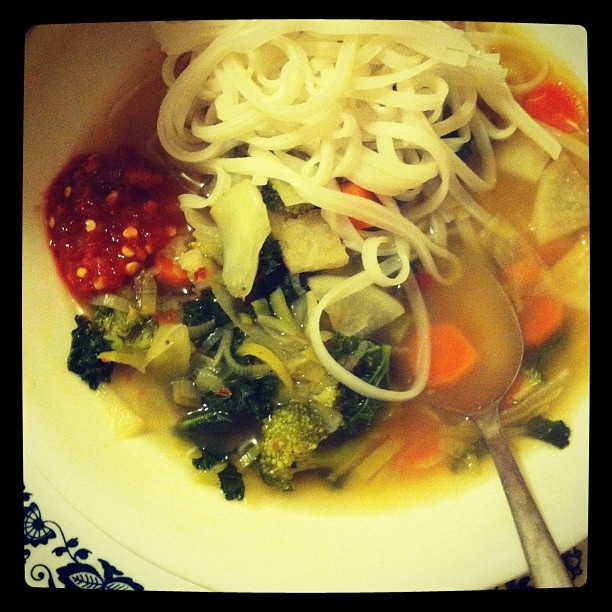Describe the objects in this image and their specific colors. I can see bowl in black, khaki, and olive tones, broccoli in black and olive tones, spoon in black, olive, tan, and orange tones, broccoli in black, olive, and khaki tones, and carrot in black, red, orange, and maroon tones in this image. 